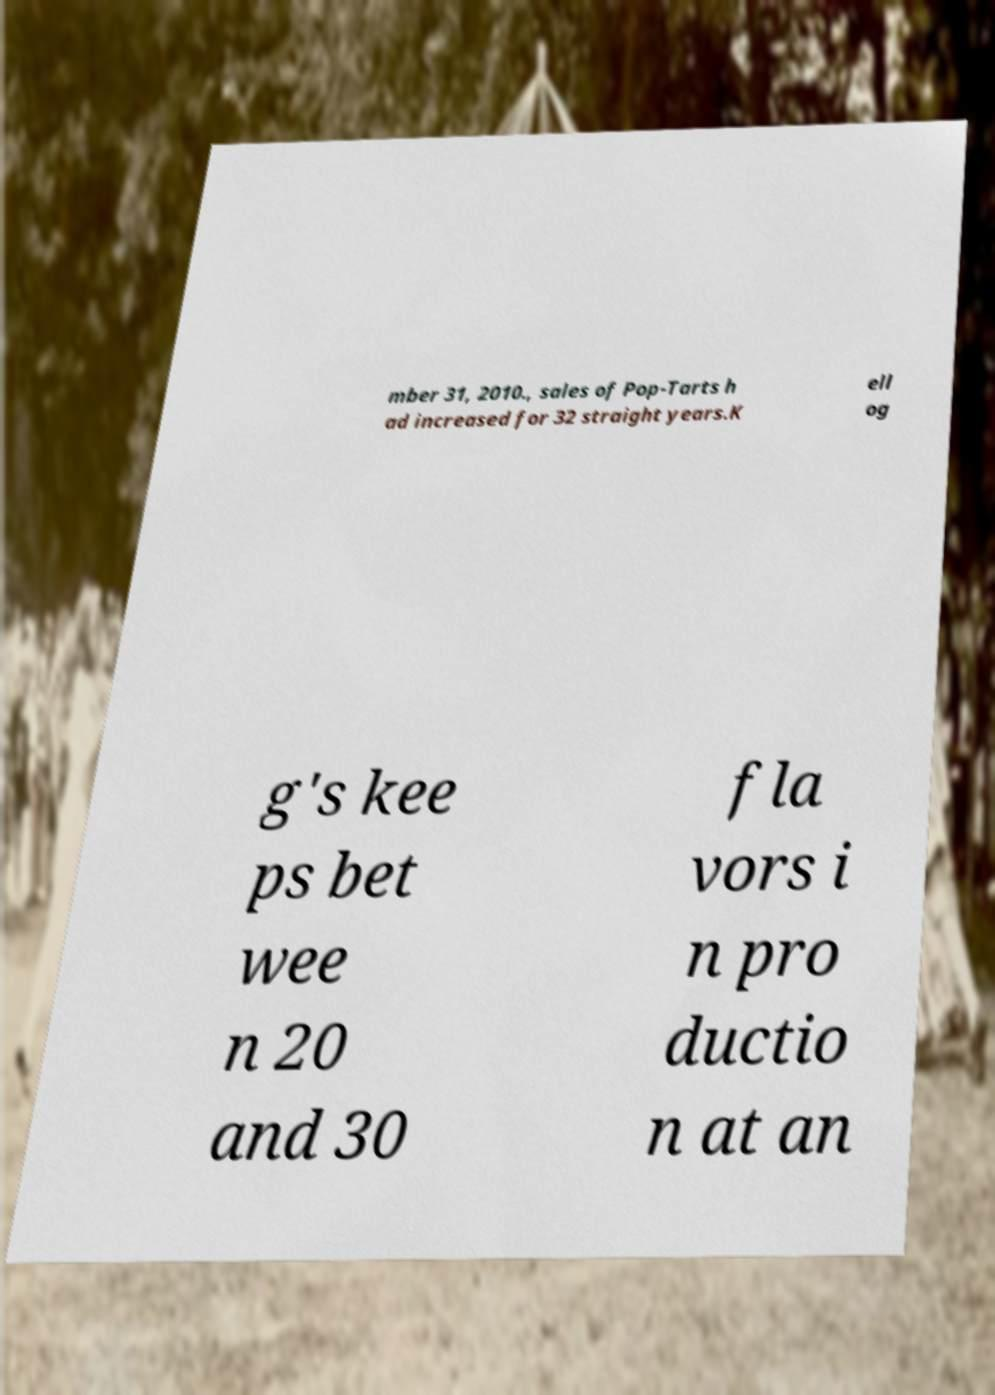For documentation purposes, I need the text within this image transcribed. Could you provide that? mber 31, 2010., sales of Pop-Tarts h ad increased for 32 straight years.K ell og g's kee ps bet wee n 20 and 30 fla vors i n pro ductio n at an 